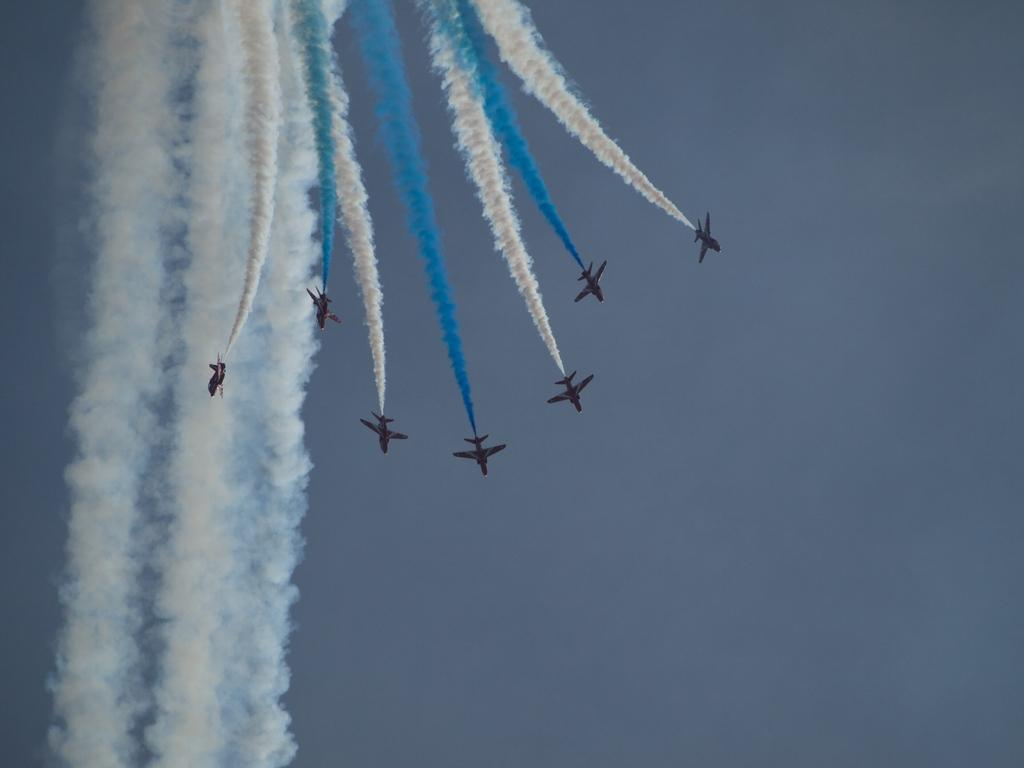What is the main subject of the image? The main subject of the image is airplanes. Where are the airplanes located in the image? The airplanes are in the center of the image. What can be seen in the background of the image? There is a sky visible in the background of the image. What is the unique feature of the airplanes in the image? Different color smoke is present in the image. How many feet are visible in the image? There are no feet visible in the image; it features airplanes and a sky background. 